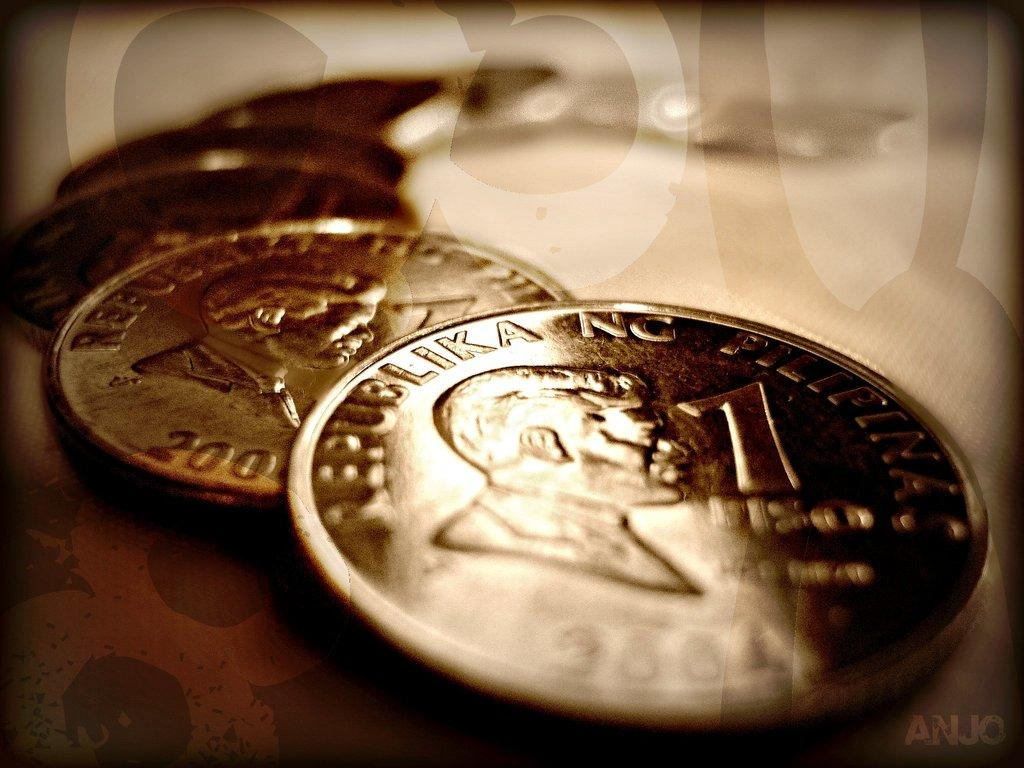<image>
Present a compact description of the photo's key features. A series of Republika coins sit stacked on top of each other. 